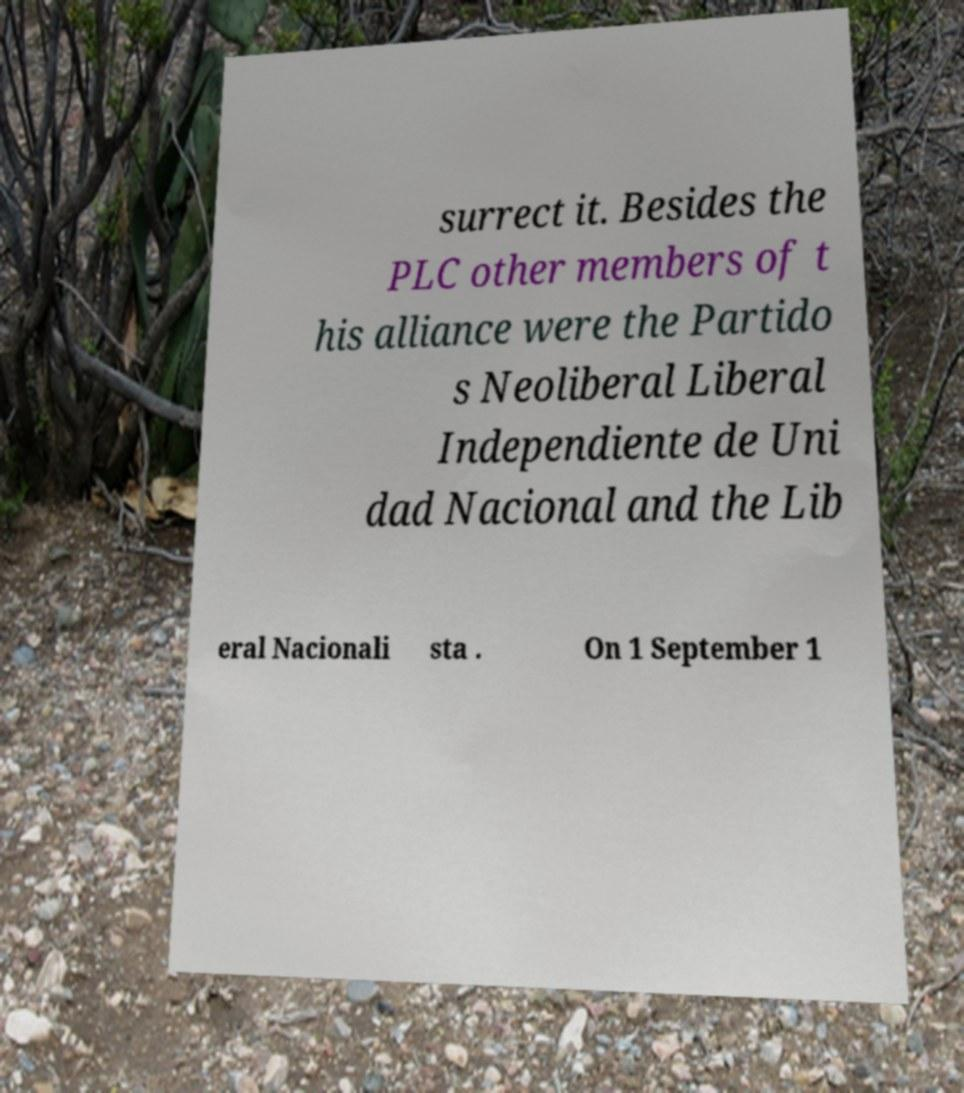Could you extract and type out the text from this image? surrect it. Besides the PLC other members of t his alliance were the Partido s Neoliberal Liberal Independiente de Uni dad Nacional and the Lib eral Nacionali sta . On 1 September 1 